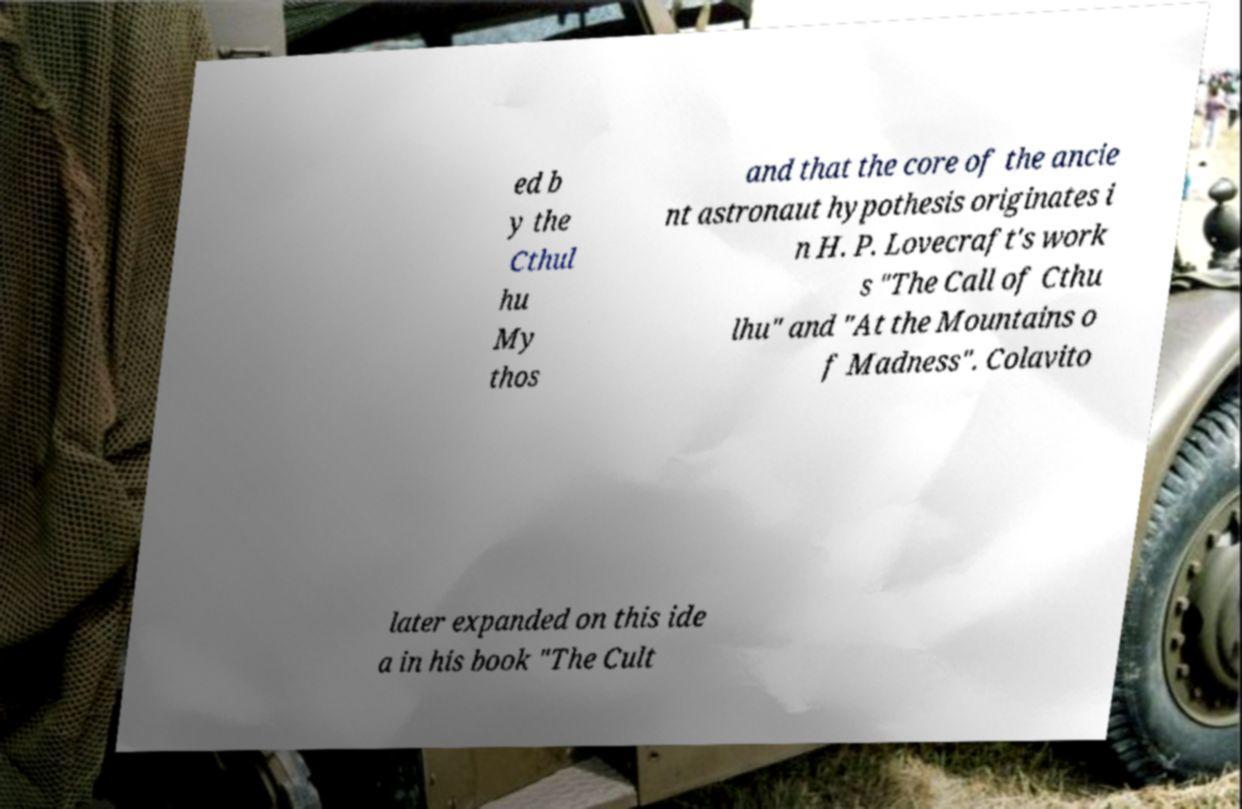Could you assist in decoding the text presented in this image and type it out clearly? ed b y the Cthul hu My thos and that the core of the ancie nt astronaut hypothesis originates i n H. P. Lovecraft's work s "The Call of Cthu lhu" and "At the Mountains o f Madness". Colavito later expanded on this ide a in his book "The Cult 